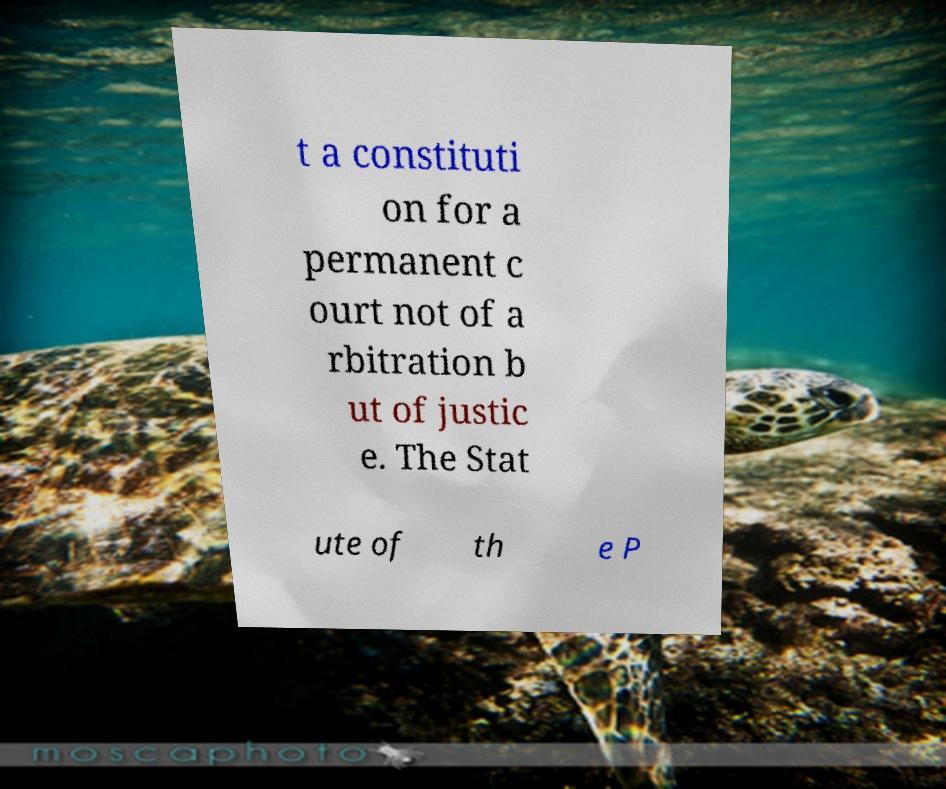I need the written content from this picture converted into text. Can you do that? t a constituti on for a permanent c ourt not of a rbitration b ut of justic e. The Stat ute of th e P 